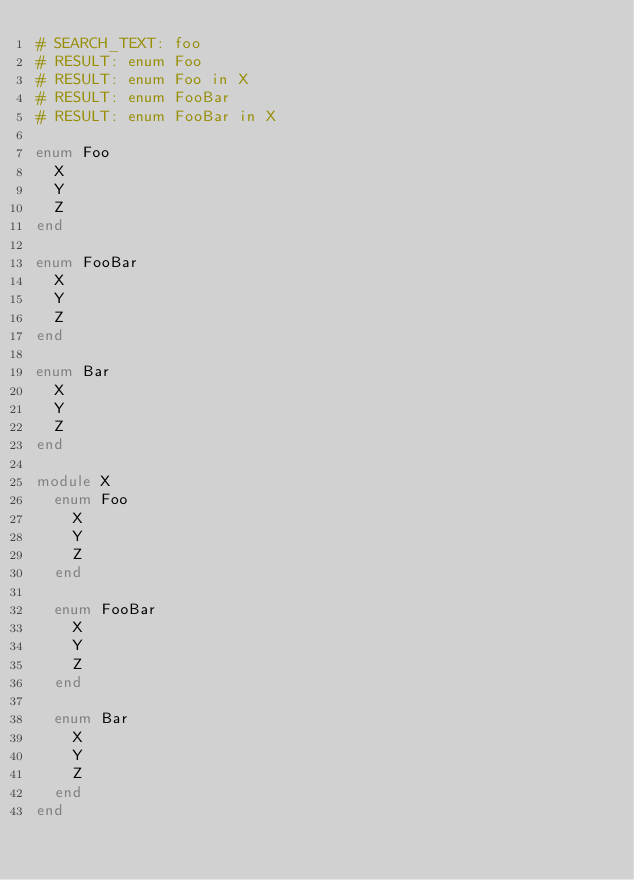<code> <loc_0><loc_0><loc_500><loc_500><_Crystal_># SEARCH_TEXT: foo
# RESULT: enum Foo
# RESULT: enum Foo in X
# RESULT: enum FooBar
# RESULT: enum FooBar in X

enum Foo
  X
  Y
  Z
end

enum FooBar
  X
  Y
  Z
end

enum Bar
  X
  Y
  Z
end

module X
  enum Foo
    X
    Y
    Z
  end

  enum FooBar
    X
    Y
    Z
  end

  enum Bar
    X
    Y
    Z
  end
end</code> 